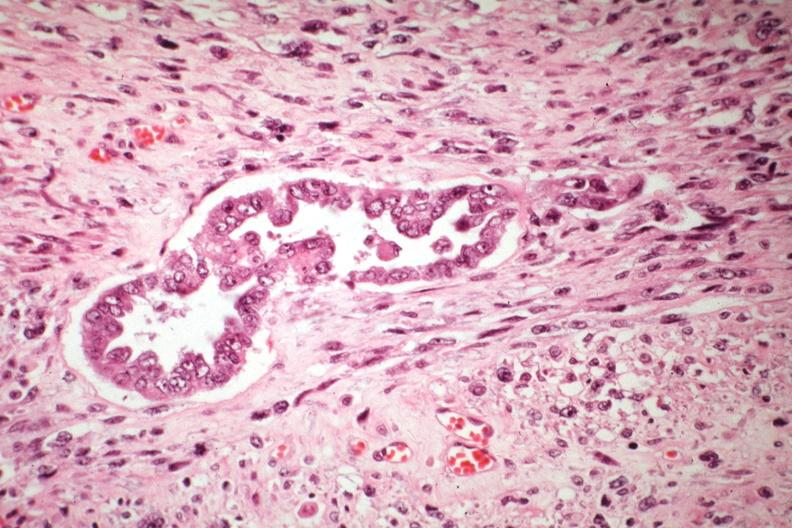s abruption present?
Answer the question using a single word or phrase. No 